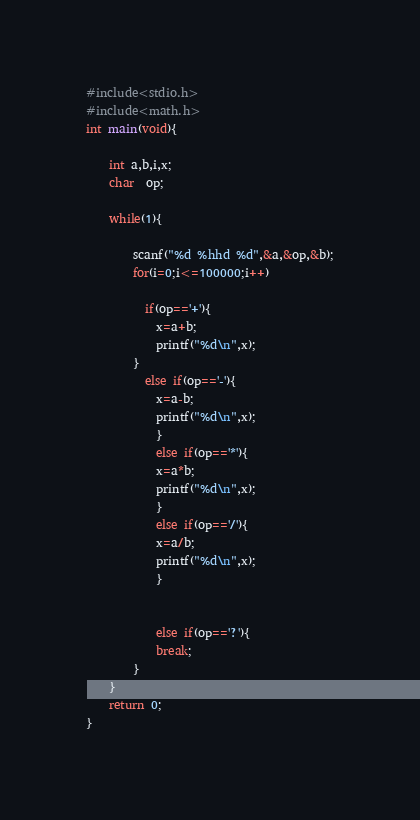Convert code to text. <code><loc_0><loc_0><loc_500><loc_500><_C_>#include<stdio.h>
#include<math.h>
int main(void){
 
	int a,b,i,x;
	char  op;

	while(1){
 
 		scanf("%d %hhd %d",&a,&op,&b);
		for(i=0;i<=100000;i++)
		
  	      if(op=='+'){
			x=a+b;
			printf("%d\n",x);
		}
  	      else if(op=='-'){
			x=a-b;
			printf("%d\n",x);
	        }
	        else if(op=='*'){
			x=a*b;
			printf("%d\n",x);
	        }
	        else if(op=='/'){
			x=a/b;
			printf("%d\n",x);
	        }
     
         
	        else if(op=='?'){
			break;
		}
 	}
	return 0;
}
</code> 